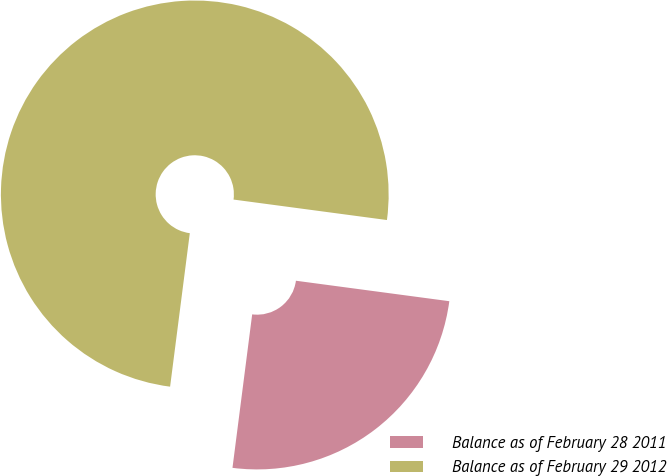<chart> <loc_0><loc_0><loc_500><loc_500><pie_chart><fcel>Balance as of February 28 2011<fcel>Balance as of February 29 2012<nl><fcel>24.92%<fcel>75.08%<nl></chart> 